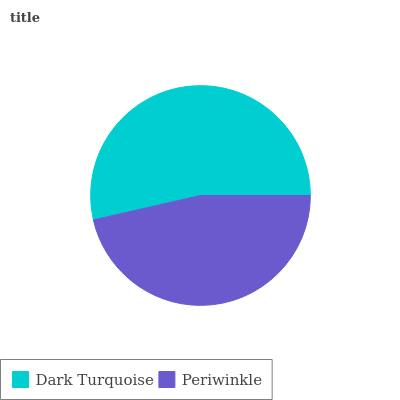Is Periwinkle the minimum?
Answer yes or no. Yes. Is Dark Turquoise the maximum?
Answer yes or no. Yes. Is Periwinkle the maximum?
Answer yes or no. No. Is Dark Turquoise greater than Periwinkle?
Answer yes or no. Yes. Is Periwinkle less than Dark Turquoise?
Answer yes or no. Yes. Is Periwinkle greater than Dark Turquoise?
Answer yes or no. No. Is Dark Turquoise less than Periwinkle?
Answer yes or no. No. Is Dark Turquoise the high median?
Answer yes or no. Yes. Is Periwinkle the low median?
Answer yes or no. Yes. Is Periwinkle the high median?
Answer yes or no. No. Is Dark Turquoise the low median?
Answer yes or no. No. 